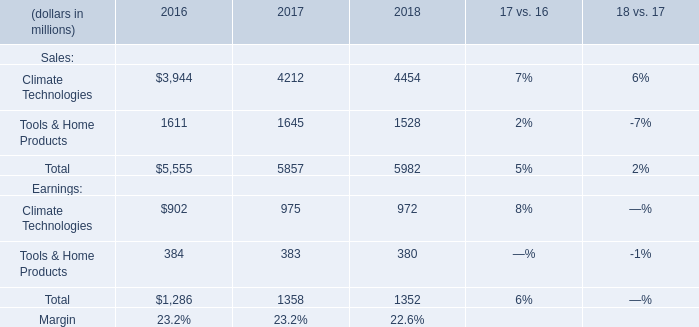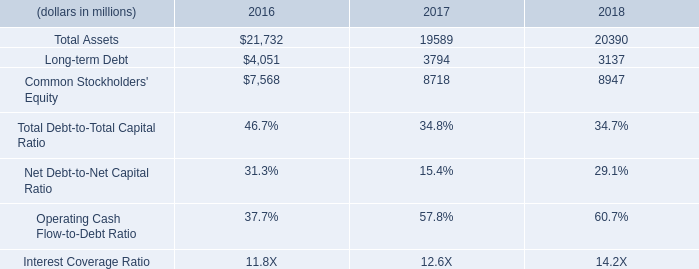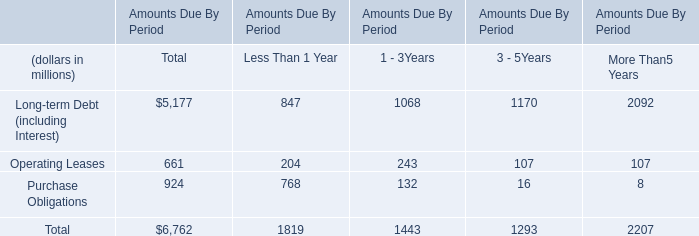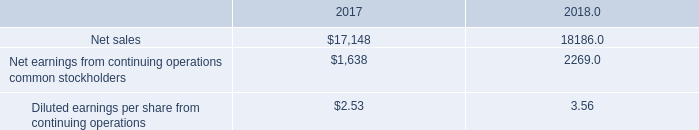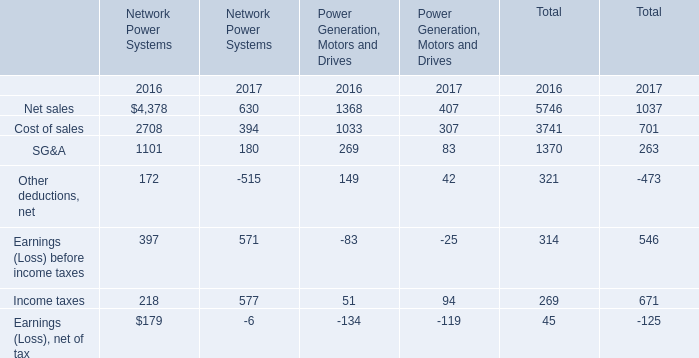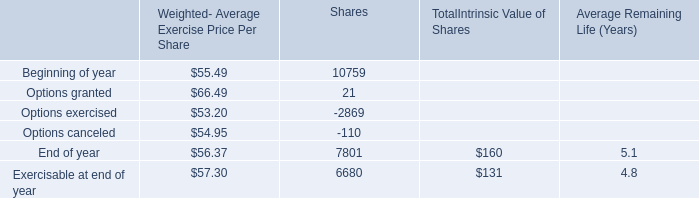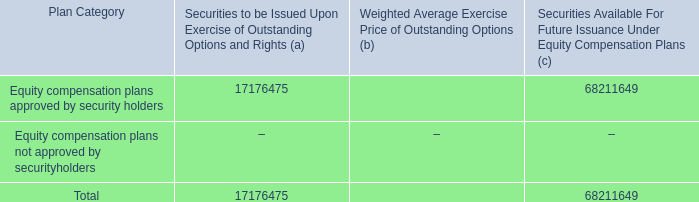If Earnings (Loss) before income taxes develops with the same increasing rate in 2017, what will it reach in 2018? 
Computations: (571 * (1 + ((571 - 397) / 397)))
Answer: 821.26196. 